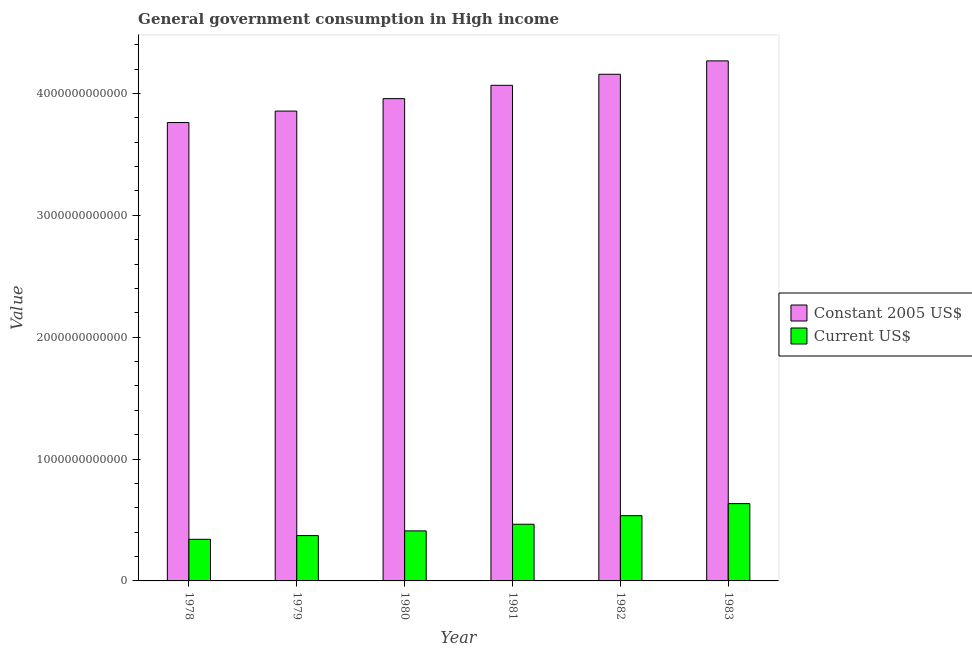How many different coloured bars are there?
Make the answer very short. 2. Are the number of bars on each tick of the X-axis equal?
Provide a succinct answer. Yes. How many bars are there on the 3rd tick from the right?
Make the answer very short. 2. In how many cases, is the number of bars for a given year not equal to the number of legend labels?
Your answer should be very brief. 0. What is the value consumed in constant 2005 us$ in 1982?
Your response must be concise. 4.16e+12. Across all years, what is the maximum value consumed in current us$?
Give a very brief answer. 6.34e+11. Across all years, what is the minimum value consumed in current us$?
Offer a very short reply. 3.42e+11. In which year was the value consumed in constant 2005 us$ maximum?
Ensure brevity in your answer.  1983. In which year was the value consumed in current us$ minimum?
Keep it short and to the point. 1978. What is the total value consumed in constant 2005 us$ in the graph?
Your answer should be very brief. 2.41e+13. What is the difference between the value consumed in constant 2005 us$ in 1982 and that in 1983?
Provide a short and direct response. -1.10e+11. What is the difference between the value consumed in constant 2005 us$ in 1981 and the value consumed in current us$ in 1983?
Your answer should be very brief. -2.00e+11. What is the average value consumed in current us$ per year?
Make the answer very short. 4.60e+11. In the year 1979, what is the difference between the value consumed in current us$ and value consumed in constant 2005 us$?
Keep it short and to the point. 0. In how many years, is the value consumed in current us$ greater than 2200000000000?
Make the answer very short. 0. What is the ratio of the value consumed in current us$ in 1979 to that in 1980?
Offer a terse response. 0.91. Is the value consumed in constant 2005 us$ in 1982 less than that in 1983?
Your response must be concise. Yes. What is the difference between the highest and the second highest value consumed in current us$?
Ensure brevity in your answer.  9.89e+1. What is the difference between the highest and the lowest value consumed in current us$?
Make the answer very short. 2.93e+11. In how many years, is the value consumed in constant 2005 us$ greater than the average value consumed in constant 2005 us$ taken over all years?
Make the answer very short. 3. What does the 2nd bar from the left in 1981 represents?
Provide a succinct answer. Current US$. What does the 1st bar from the right in 1981 represents?
Give a very brief answer. Current US$. How many bars are there?
Your answer should be very brief. 12. Are all the bars in the graph horizontal?
Your answer should be very brief. No. How many years are there in the graph?
Keep it short and to the point. 6. What is the difference between two consecutive major ticks on the Y-axis?
Provide a succinct answer. 1.00e+12. How many legend labels are there?
Provide a succinct answer. 2. How are the legend labels stacked?
Give a very brief answer. Vertical. What is the title of the graph?
Your response must be concise. General government consumption in High income. What is the label or title of the Y-axis?
Your response must be concise. Value. What is the Value of Constant 2005 US$ in 1978?
Your answer should be compact. 3.76e+12. What is the Value of Current US$ in 1978?
Give a very brief answer. 3.42e+11. What is the Value of Constant 2005 US$ in 1979?
Your answer should be very brief. 3.86e+12. What is the Value in Current US$ in 1979?
Your answer should be compact. 3.72e+11. What is the Value of Constant 2005 US$ in 1980?
Make the answer very short. 3.96e+12. What is the Value in Current US$ in 1980?
Ensure brevity in your answer.  4.11e+11. What is the Value of Constant 2005 US$ in 1981?
Keep it short and to the point. 4.07e+12. What is the Value of Current US$ in 1981?
Make the answer very short. 4.65e+11. What is the Value of Constant 2005 US$ in 1982?
Make the answer very short. 4.16e+12. What is the Value of Current US$ in 1982?
Offer a very short reply. 5.35e+11. What is the Value in Constant 2005 US$ in 1983?
Your answer should be very brief. 4.27e+12. What is the Value in Current US$ in 1983?
Your response must be concise. 6.34e+11. Across all years, what is the maximum Value of Constant 2005 US$?
Provide a short and direct response. 4.27e+12. Across all years, what is the maximum Value in Current US$?
Make the answer very short. 6.34e+11. Across all years, what is the minimum Value in Constant 2005 US$?
Provide a succinct answer. 3.76e+12. Across all years, what is the minimum Value in Current US$?
Make the answer very short. 3.42e+11. What is the total Value in Constant 2005 US$ in the graph?
Offer a very short reply. 2.41e+13. What is the total Value of Current US$ in the graph?
Offer a very short reply. 2.76e+12. What is the difference between the Value of Constant 2005 US$ in 1978 and that in 1979?
Make the answer very short. -9.39e+1. What is the difference between the Value in Current US$ in 1978 and that in 1979?
Offer a terse response. -3.05e+1. What is the difference between the Value in Constant 2005 US$ in 1978 and that in 1980?
Ensure brevity in your answer.  -1.96e+11. What is the difference between the Value of Current US$ in 1978 and that in 1980?
Keep it short and to the point. -6.91e+1. What is the difference between the Value in Constant 2005 US$ in 1978 and that in 1981?
Keep it short and to the point. -3.05e+11. What is the difference between the Value in Current US$ in 1978 and that in 1981?
Your response must be concise. -1.24e+11. What is the difference between the Value of Constant 2005 US$ in 1978 and that in 1982?
Provide a short and direct response. -3.96e+11. What is the difference between the Value in Current US$ in 1978 and that in 1982?
Make the answer very short. -1.94e+11. What is the difference between the Value in Constant 2005 US$ in 1978 and that in 1983?
Your answer should be compact. -5.06e+11. What is the difference between the Value of Current US$ in 1978 and that in 1983?
Keep it short and to the point. -2.93e+11. What is the difference between the Value in Constant 2005 US$ in 1979 and that in 1980?
Offer a terse response. -1.02e+11. What is the difference between the Value in Current US$ in 1979 and that in 1980?
Keep it short and to the point. -3.85e+1. What is the difference between the Value in Constant 2005 US$ in 1979 and that in 1981?
Make the answer very short. -2.12e+11. What is the difference between the Value in Current US$ in 1979 and that in 1981?
Offer a terse response. -9.30e+1. What is the difference between the Value of Constant 2005 US$ in 1979 and that in 1982?
Ensure brevity in your answer.  -3.02e+11. What is the difference between the Value in Current US$ in 1979 and that in 1982?
Your answer should be very brief. -1.63e+11. What is the difference between the Value in Constant 2005 US$ in 1979 and that in 1983?
Make the answer very short. -4.12e+11. What is the difference between the Value in Current US$ in 1979 and that in 1983?
Give a very brief answer. -2.62e+11. What is the difference between the Value of Constant 2005 US$ in 1980 and that in 1981?
Give a very brief answer. -1.09e+11. What is the difference between the Value of Current US$ in 1980 and that in 1981?
Provide a succinct answer. -5.45e+1. What is the difference between the Value in Constant 2005 US$ in 1980 and that in 1982?
Provide a succinct answer. -2.00e+11. What is the difference between the Value in Current US$ in 1980 and that in 1982?
Your response must be concise. -1.25e+11. What is the difference between the Value of Constant 2005 US$ in 1980 and that in 1983?
Provide a short and direct response. -3.10e+11. What is the difference between the Value in Current US$ in 1980 and that in 1983?
Give a very brief answer. -2.24e+11. What is the difference between the Value of Constant 2005 US$ in 1981 and that in 1982?
Your answer should be compact. -9.06e+1. What is the difference between the Value in Current US$ in 1981 and that in 1982?
Provide a succinct answer. -7.03e+1. What is the difference between the Value in Constant 2005 US$ in 1981 and that in 1983?
Your response must be concise. -2.00e+11. What is the difference between the Value of Current US$ in 1981 and that in 1983?
Offer a very short reply. -1.69e+11. What is the difference between the Value in Constant 2005 US$ in 1982 and that in 1983?
Your answer should be very brief. -1.10e+11. What is the difference between the Value of Current US$ in 1982 and that in 1983?
Offer a terse response. -9.89e+1. What is the difference between the Value in Constant 2005 US$ in 1978 and the Value in Current US$ in 1979?
Make the answer very short. 3.39e+12. What is the difference between the Value in Constant 2005 US$ in 1978 and the Value in Current US$ in 1980?
Provide a short and direct response. 3.35e+12. What is the difference between the Value in Constant 2005 US$ in 1978 and the Value in Current US$ in 1981?
Provide a succinct answer. 3.30e+12. What is the difference between the Value in Constant 2005 US$ in 1978 and the Value in Current US$ in 1982?
Give a very brief answer. 3.23e+12. What is the difference between the Value of Constant 2005 US$ in 1978 and the Value of Current US$ in 1983?
Your answer should be compact. 3.13e+12. What is the difference between the Value in Constant 2005 US$ in 1979 and the Value in Current US$ in 1980?
Your response must be concise. 3.44e+12. What is the difference between the Value of Constant 2005 US$ in 1979 and the Value of Current US$ in 1981?
Ensure brevity in your answer.  3.39e+12. What is the difference between the Value of Constant 2005 US$ in 1979 and the Value of Current US$ in 1982?
Keep it short and to the point. 3.32e+12. What is the difference between the Value of Constant 2005 US$ in 1979 and the Value of Current US$ in 1983?
Ensure brevity in your answer.  3.22e+12. What is the difference between the Value in Constant 2005 US$ in 1980 and the Value in Current US$ in 1981?
Make the answer very short. 3.49e+12. What is the difference between the Value of Constant 2005 US$ in 1980 and the Value of Current US$ in 1982?
Your answer should be very brief. 3.42e+12. What is the difference between the Value of Constant 2005 US$ in 1980 and the Value of Current US$ in 1983?
Make the answer very short. 3.32e+12. What is the difference between the Value of Constant 2005 US$ in 1981 and the Value of Current US$ in 1982?
Offer a terse response. 3.53e+12. What is the difference between the Value of Constant 2005 US$ in 1981 and the Value of Current US$ in 1983?
Ensure brevity in your answer.  3.43e+12. What is the difference between the Value in Constant 2005 US$ in 1982 and the Value in Current US$ in 1983?
Your answer should be compact. 3.52e+12. What is the average Value of Constant 2005 US$ per year?
Offer a very short reply. 4.01e+12. What is the average Value in Current US$ per year?
Provide a short and direct response. 4.60e+11. In the year 1978, what is the difference between the Value of Constant 2005 US$ and Value of Current US$?
Offer a terse response. 3.42e+12. In the year 1979, what is the difference between the Value in Constant 2005 US$ and Value in Current US$?
Your answer should be compact. 3.48e+12. In the year 1980, what is the difference between the Value of Constant 2005 US$ and Value of Current US$?
Your answer should be very brief. 3.55e+12. In the year 1981, what is the difference between the Value in Constant 2005 US$ and Value in Current US$?
Your answer should be compact. 3.60e+12. In the year 1982, what is the difference between the Value in Constant 2005 US$ and Value in Current US$?
Your answer should be compact. 3.62e+12. In the year 1983, what is the difference between the Value in Constant 2005 US$ and Value in Current US$?
Make the answer very short. 3.63e+12. What is the ratio of the Value of Constant 2005 US$ in 1978 to that in 1979?
Give a very brief answer. 0.98. What is the ratio of the Value of Current US$ in 1978 to that in 1979?
Keep it short and to the point. 0.92. What is the ratio of the Value of Constant 2005 US$ in 1978 to that in 1980?
Make the answer very short. 0.95. What is the ratio of the Value of Current US$ in 1978 to that in 1980?
Ensure brevity in your answer.  0.83. What is the ratio of the Value in Constant 2005 US$ in 1978 to that in 1981?
Give a very brief answer. 0.92. What is the ratio of the Value in Current US$ in 1978 to that in 1981?
Provide a short and direct response. 0.73. What is the ratio of the Value in Constant 2005 US$ in 1978 to that in 1982?
Keep it short and to the point. 0.9. What is the ratio of the Value in Current US$ in 1978 to that in 1982?
Give a very brief answer. 0.64. What is the ratio of the Value of Constant 2005 US$ in 1978 to that in 1983?
Your response must be concise. 0.88. What is the ratio of the Value in Current US$ in 1978 to that in 1983?
Provide a succinct answer. 0.54. What is the ratio of the Value in Constant 2005 US$ in 1979 to that in 1980?
Your answer should be compact. 0.97. What is the ratio of the Value in Current US$ in 1979 to that in 1980?
Offer a very short reply. 0.91. What is the ratio of the Value of Constant 2005 US$ in 1979 to that in 1981?
Offer a very short reply. 0.95. What is the ratio of the Value of Constant 2005 US$ in 1979 to that in 1982?
Your answer should be very brief. 0.93. What is the ratio of the Value of Current US$ in 1979 to that in 1982?
Offer a very short reply. 0.69. What is the ratio of the Value in Constant 2005 US$ in 1979 to that in 1983?
Offer a terse response. 0.9. What is the ratio of the Value of Current US$ in 1979 to that in 1983?
Give a very brief answer. 0.59. What is the ratio of the Value of Constant 2005 US$ in 1980 to that in 1981?
Offer a very short reply. 0.97. What is the ratio of the Value of Current US$ in 1980 to that in 1981?
Your answer should be very brief. 0.88. What is the ratio of the Value of Constant 2005 US$ in 1980 to that in 1982?
Your answer should be very brief. 0.95. What is the ratio of the Value of Current US$ in 1980 to that in 1982?
Ensure brevity in your answer.  0.77. What is the ratio of the Value in Constant 2005 US$ in 1980 to that in 1983?
Provide a succinct answer. 0.93. What is the ratio of the Value in Current US$ in 1980 to that in 1983?
Keep it short and to the point. 0.65. What is the ratio of the Value of Constant 2005 US$ in 1981 to that in 1982?
Offer a terse response. 0.98. What is the ratio of the Value of Current US$ in 1981 to that in 1982?
Provide a succinct answer. 0.87. What is the ratio of the Value in Constant 2005 US$ in 1981 to that in 1983?
Keep it short and to the point. 0.95. What is the ratio of the Value in Current US$ in 1981 to that in 1983?
Provide a short and direct response. 0.73. What is the ratio of the Value of Constant 2005 US$ in 1982 to that in 1983?
Give a very brief answer. 0.97. What is the ratio of the Value of Current US$ in 1982 to that in 1983?
Keep it short and to the point. 0.84. What is the difference between the highest and the second highest Value in Constant 2005 US$?
Your response must be concise. 1.10e+11. What is the difference between the highest and the second highest Value in Current US$?
Your answer should be compact. 9.89e+1. What is the difference between the highest and the lowest Value in Constant 2005 US$?
Make the answer very short. 5.06e+11. What is the difference between the highest and the lowest Value in Current US$?
Give a very brief answer. 2.93e+11. 